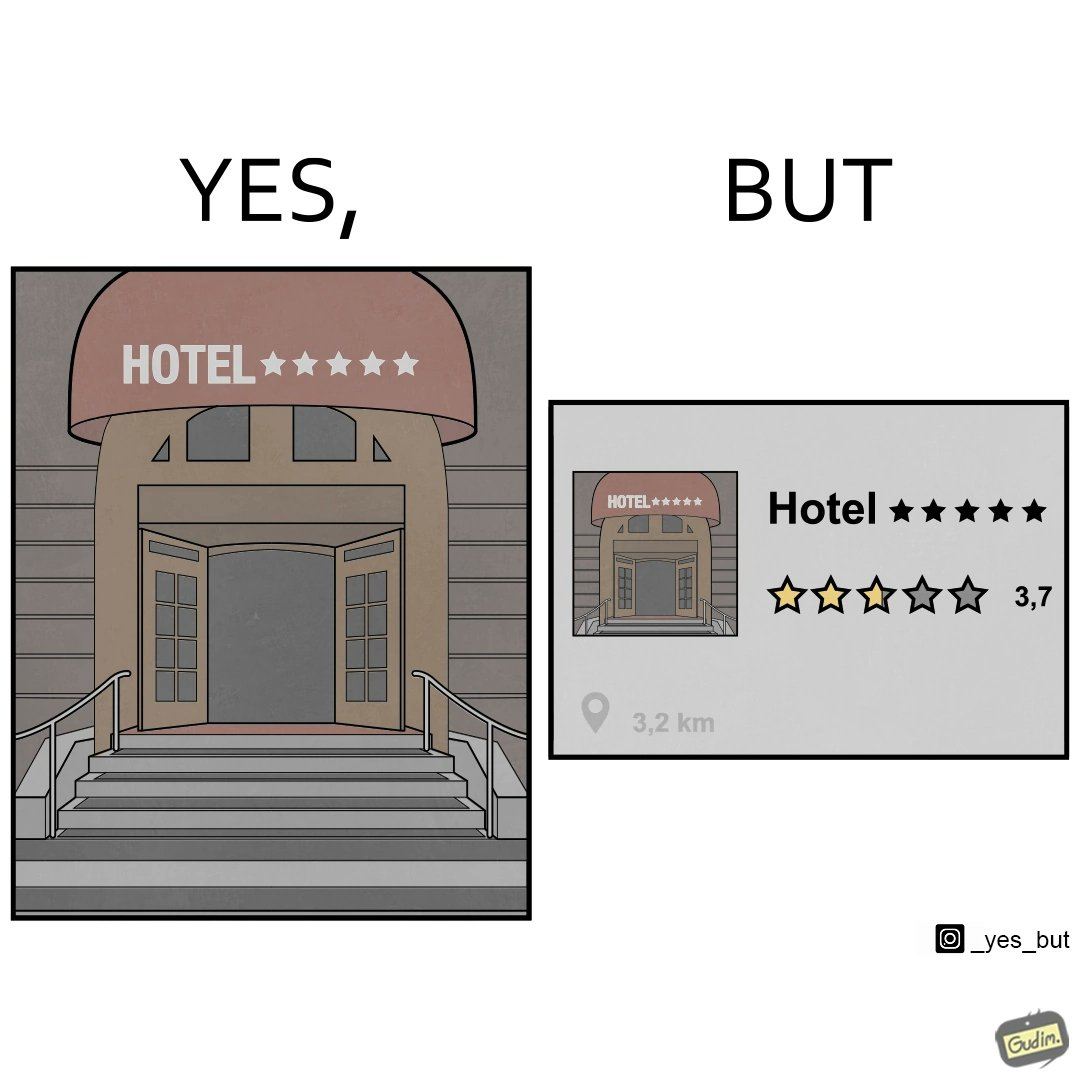What does this image depict? The image is funny because the Hotel's name suggests that it is very good and as it's name itself is Hotel 5 stars but in reality it received a rating of only 3.7 out of 5 